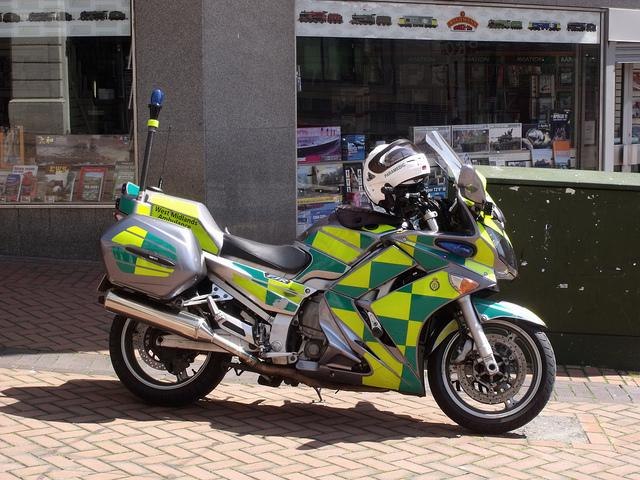The markings on the fairings of the motorcycle indicate that it belongs to which type of public organization? police 